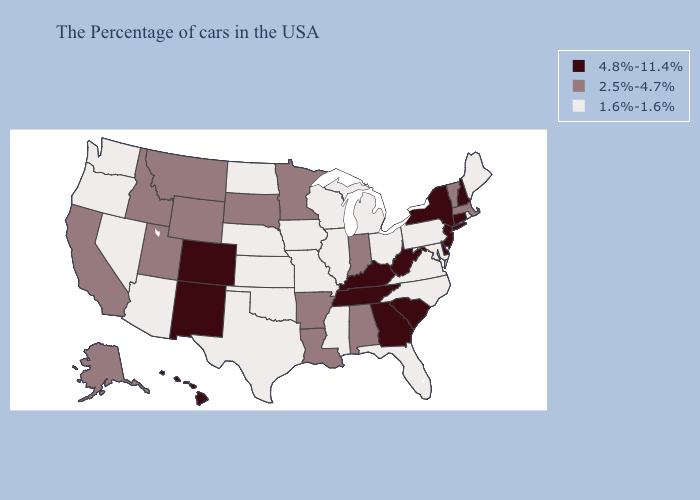Is the legend a continuous bar?
Be succinct. No. Name the states that have a value in the range 4.8%-11.4%?
Answer briefly. New Hampshire, Connecticut, New York, New Jersey, Delaware, South Carolina, West Virginia, Georgia, Kentucky, Tennessee, Colorado, New Mexico, Hawaii. What is the highest value in states that border Oklahoma?
Keep it brief. 4.8%-11.4%. Does New Hampshire have the highest value in the USA?
Give a very brief answer. Yes. Name the states that have a value in the range 2.5%-4.7%?
Keep it brief. Massachusetts, Vermont, Indiana, Alabama, Louisiana, Arkansas, Minnesota, South Dakota, Wyoming, Utah, Montana, Idaho, California, Alaska. What is the value of Virginia?
Answer briefly. 1.6%-1.6%. Among the states that border South Dakota , does Montana have the lowest value?
Quick response, please. No. Which states have the highest value in the USA?
Concise answer only. New Hampshire, Connecticut, New York, New Jersey, Delaware, South Carolina, West Virginia, Georgia, Kentucky, Tennessee, Colorado, New Mexico, Hawaii. Among the states that border Mississippi , does Tennessee have the lowest value?
Short answer required. No. Name the states that have a value in the range 1.6%-1.6%?
Keep it brief. Maine, Rhode Island, Maryland, Pennsylvania, Virginia, North Carolina, Ohio, Florida, Michigan, Wisconsin, Illinois, Mississippi, Missouri, Iowa, Kansas, Nebraska, Oklahoma, Texas, North Dakota, Arizona, Nevada, Washington, Oregon. What is the lowest value in the USA?
Keep it brief. 1.6%-1.6%. Does South Carolina have the lowest value in the South?
Short answer required. No. Among the states that border Wyoming , which have the lowest value?
Short answer required. Nebraska. Name the states that have a value in the range 4.8%-11.4%?
Be succinct. New Hampshire, Connecticut, New York, New Jersey, Delaware, South Carolina, West Virginia, Georgia, Kentucky, Tennessee, Colorado, New Mexico, Hawaii. Name the states that have a value in the range 1.6%-1.6%?
Give a very brief answer. Maine, Rhode Island, Maryland, Pennsylvania, Virginia, North Carolina, Ohio, Florida, Michigan, Wisconsin, Illinois, Mississippi, Missouri, Iowa, Kansas, Nebraska, Oklahoma, Texas, North Dakota, Arizona, Nevada, Washington, Oregon. 